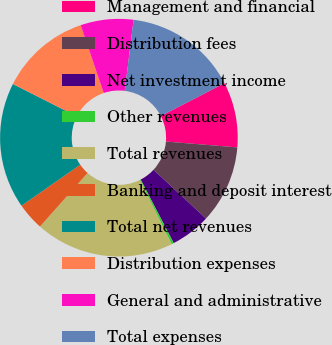Convert chart to OTSL. <chart><loc_0><loc_0><loc_500><loc_500><pie_chart><fcel>Management and financial<fcel>Distribution fees<fcel>Net investment income<fcel>Other revenues<fcel>Total revenues<fcel>Banking and deposit interest<fcel>Total net revenues<fcel>Distribution expenses<fcel>General and administrative<fcel>Total expenses<nl><fcel>8.89%<fcel>10.61%<fcel>5.46%<fcel>0.31%<fcel>18.88%<fcel>3.74%<fcel>17.16%<fcel>12.33%<fcel>7.18%<fcel>15.44%<nl></chart> 